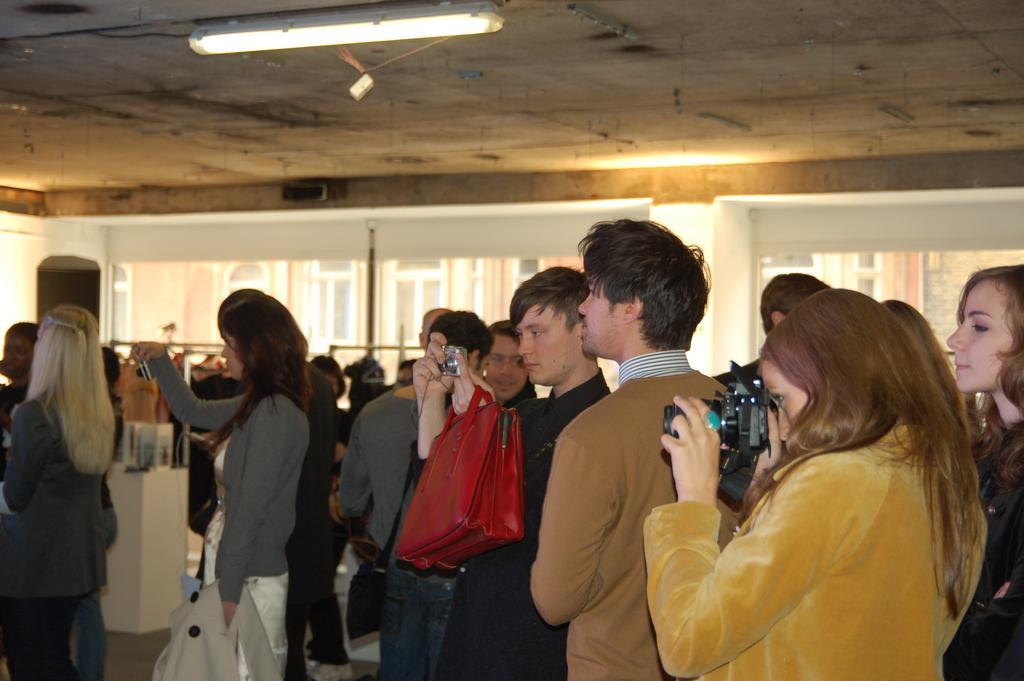Could you give a brief overview of what you see in this image? In this image, there are groups of people standing. Among them few people are holding the cameras. In the background, I can see the clothes to the hangers and there are few objects. I can see a building through the glass windows. At the top of the image, there is a tube light attached to the ceiling. 